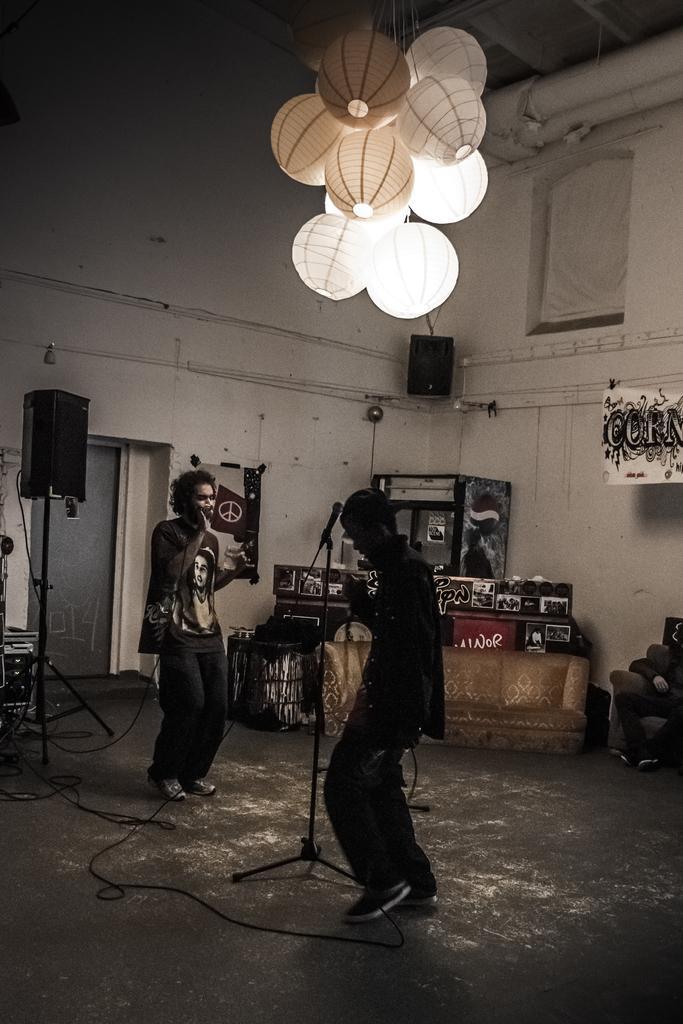In one or two sentences, can you explain what this image depicts? In this image we can see two persons standing and there is a mic between them, there is a couch and a person sitting on the chair, there is a speaker and banners to the wall, a speaker to the stand, lights hanged to the ceiling and few objects in the background. 